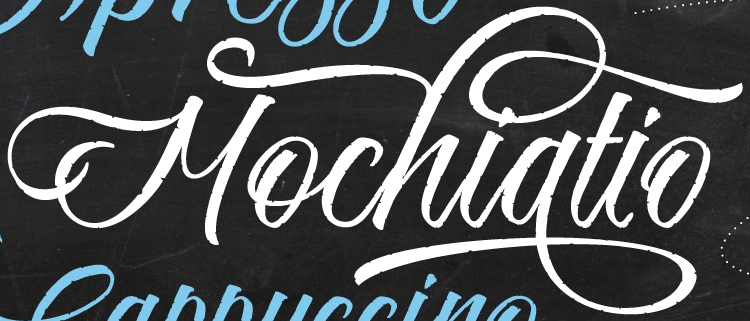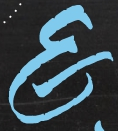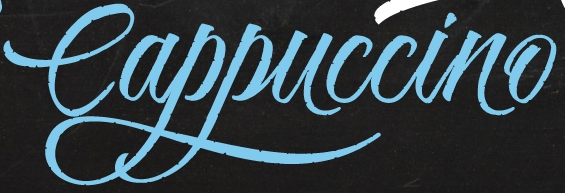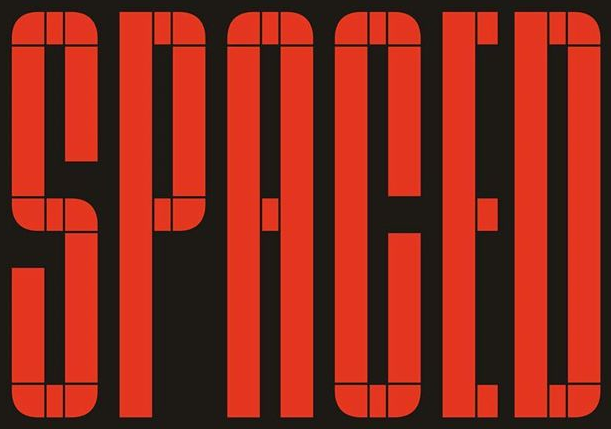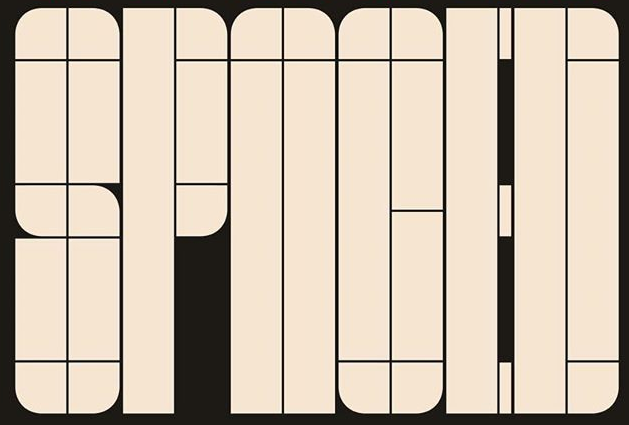Read the text from these images in sequence, separated by a semicolon. Mochiatio; E; Cappuccino; SPACED; SPNOED 